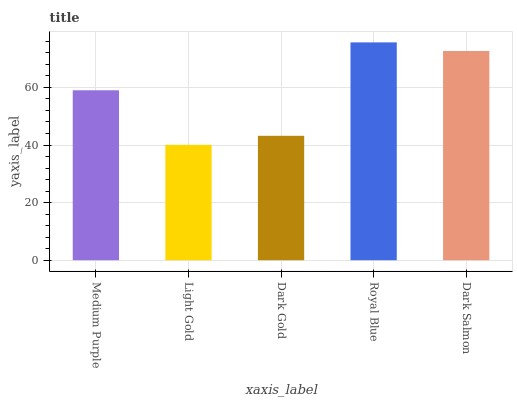Is Light Gold the minimum?
Answer yes or no. Yes. Is Royal Blue the maximum?
Answer yes or no. Yes. Is Dark Gold the minimum?
Answer yes or no. No. Is Dark Gold the maximum?
Answer yes or no. No. Is Dark Gold greater than Light Gold?
Answer yes or no. Yes. Is Light Gold less than Dark Gold?
Answer yes or no. Yes. Is Light Gold greater than Dark Gold?
Answer yes or no. No. Is Dark Gold less than Light Gold?
Answer yes or no. No. Is Medium Purple the high median?
Answer yes or no. Yes. Is Medium Purple the low median?
Answer yes or no. Yes. Is Royal Blue the high median?
Answer yes or no. No. Is Royal Blue the low median?
Answer yes or no. No. 